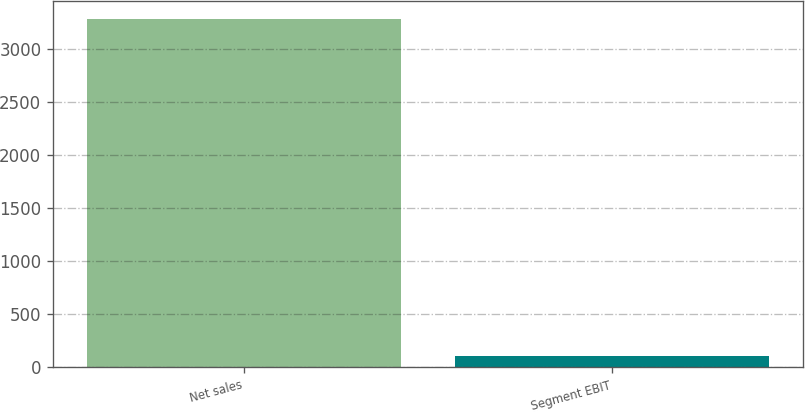<chart> <loc_0><loc_0><loc_500><loc_500><bar_chart><fcel>Net sales<fcel>Segment EBIT<nl><fcel>3284<fcel>102<nl></chart> 